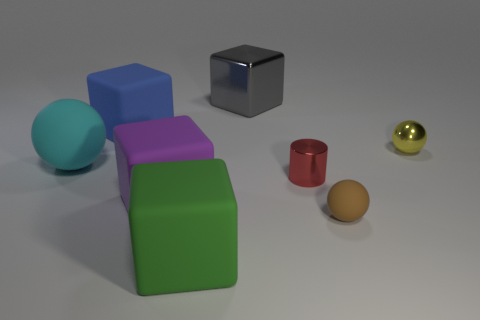There is a yellow object that is the same shape as the big cyan matte thing; what is it made of?
Your answer should be compact. Metal. Is the big cyan thing the same shape as the purple matte thing?
Your answer should be compact. No. How many yellow metal spheres are behind the large gray cube?
Your answer should be compact. 0. There is a tiny thing left of the matte sphere to the right of the gray shiny block; what shape is it?
Keep it short and to the point. Cylinder. What is the shape of the other small object that is the same material as the tiny yellow object?
Give a very brief answer. Cylinder. Is the size of the sphere that is on the left side of the big gray metallic block the same as the rubber cube that is behind the large ball?
Ensure brevity in your answer.  Yes. The rubber thing that is right of the gray metallic cube has what shape?
Ensure brevity in your answer.  Sphere. What color is the shiny ball?
Provide a succinct answer. Yellow. There is a blue matte object; does it have the same size as the metallic object in front of the cyan ball?
Your answer should be very brief. No. What number of shiny objects are either blocks or purple objects?
Keep it short and to the point. 1. 